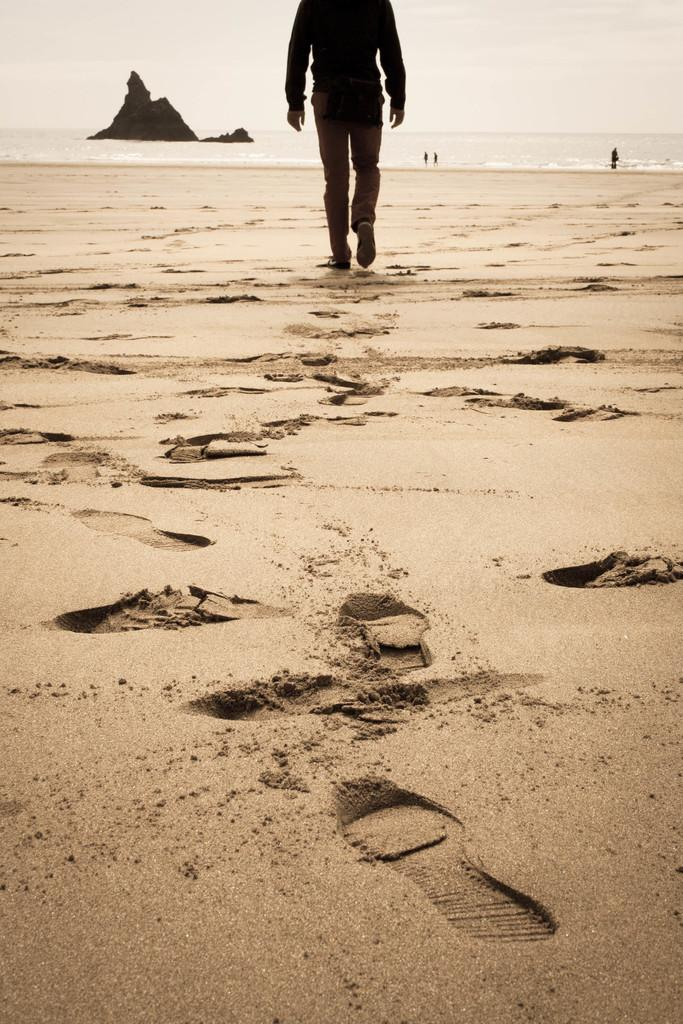What is the main subject of the image? The main subject of the image is a person walking on the beach. What is the unusual feature in the ocean? There is a small hill in the ocean in the image. What are the people near the hill doing? There are people walking in the water near the hill. What can be seen above the land and ocean in the image? The sky is visible in the image. What type of glass can be seen floating in the stream near the board in the image? There is no glass, stream, or board present in the image. 